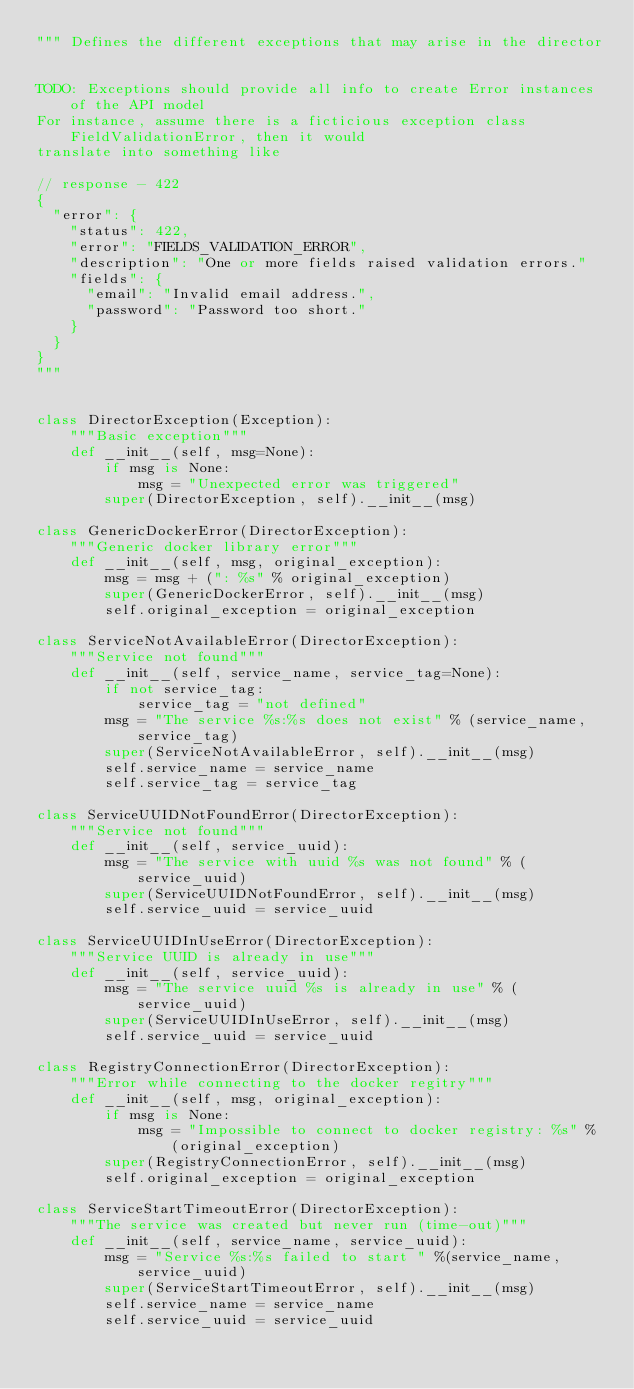<code> <loc_0><loc_0><loc_500><loc_500><_Python_>""" Defines the different exceptions that may arise in the director


TODO: Exceptions should provide all info to create Error instances of the API model
For instance, assume there is a ficticious exception class FieldValidationError, then it would
translate into something like

// response - 422
{
  "error": {
    "status": 422,
    "error": "FIELDS_VALIDATION_ERROR",
    "description": "One or more fields raised validation errors."
    "fields": {
      "email": "Invalid email address.",
      "password": "Password too short."
    }
  }
}
"""


class DirectorException(Exception):
    """Basic exception"""
    def __init__(self, msg=None):
        if msg is None:
            msg = "Unexpected error was triggered"
        super(DirectorException, self).__init__(msg)

class GenericDockerError(DirectorException):
    """Generic docker library error"""
    def __init__(self, msg, original_exception):
        msg = msg + (": %s" % original_exception)
        super(GenericDockerError, self).__init__(msg)
        self.original_exception = original_exception

class ServiceNotAvailableError(DirectorException):
    """Service not found"""
    def __init__(self, service_name, service_tag=None):
        if not service_tag:
            service_tag = "not defined"
        msg = "The service %s:%s does not exist" % (service_name, service_tag)
        super(ServiceNotAvailableError, self).__init__(msg)
        self.service_name = service_name
        self.service_tag = service_tag

class ServiceUUIDNotFoundError(DirectorException):
    """Service not found"""
    def __init__(self, service_uuid):
        msg = "The service with uuid %s was not found" % (service_uuid)
        super(ServiceUUIDNotFoundError, self).__init__(msg)
        self.service_uuid = service_uuid

class ServiceUUIDInUseError(DirectorException):
    """Service UUID is already in use"""
    def __init__(self, service_uuid):
        msg = "The service uuid %s is already in use" % (service_uuid)
        super(ServiceUUIDInUseError, self).__init__(msg)
        self.service_uuid = service_uuid

class RegistryConnectionError(DirectorException):
    """Error while connecting to the docker regitry"""
    def __init__(self, msg, original_exception):
        if msg is None:
            msg = "Impossible to connect to docker registry: %s" % (original_exception)
        super(RegistryConnectionError, self).__init__(msg)
        self.original_exception = original_exception

class ServiceStartTimeoutError(DirectorException):
    """The service was created but never run (time-out)"""
    def __init__(self, service_name, service_uuid):
        msg = "Service %s:%s failed to start " %(service_name, service_uuid)
        super(ServiceStartTimeoutError, self).__init__(msg)
        self.service_name = service_name
        self.service_uuid = service_uuid
</code> 